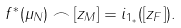<formula> <loc_0><loc_0><loc_500><loc_500>f ^ { * } ( \mu _ { N } ) \frown [ z _ { M } ] = i _ { 1 _ { * } } ( [ z _ { F } ] ) .</formula> 